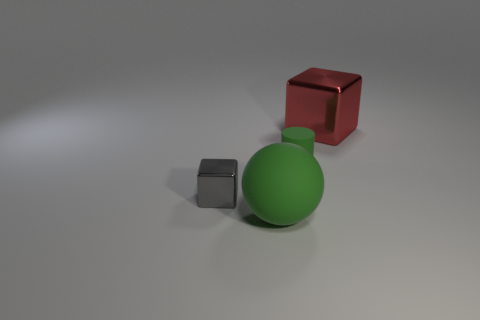There is a large thing that is behind the cube that is to the left of the large red metal block; how many objects are on the right side of it?
Offer a terse response. 0. There is a tiny cylinder that is the same color as the big matte object; what material is it?
Keep it short and to the point. Rubber. Is the number of red blocks greater than the number of small cyan rubber spheres?
Give a very brief answer. Yes. Is the red metallic block the same size as the gray cube?
Offer a terse response. No. How many things are gray metal objects or small green metallic objects?
Your answer should be compact. 1. There is a large object in front of the shiny block in front of the shiny cube behind the gray metal block; what is its shape?
Give a very brief answer. Sphere. Is the material of the big thing on the right side of the big sphere the same as the cube that is to the left of the large metal cube?
Offer a very short reply. Yes. What is the material of the other thing that is the same shape as the tiny gray object?
Make the answer very short. Metal. Is there any other thing that has the same size as the green rubber cylinder?
Your answer should be very brief. Yes. There is a metallic object that is on the right side of the large green thing; does it have the same shape as the big thing that is in front of the tiny green rubber cylinder?
Provide a succinct answer. No. 